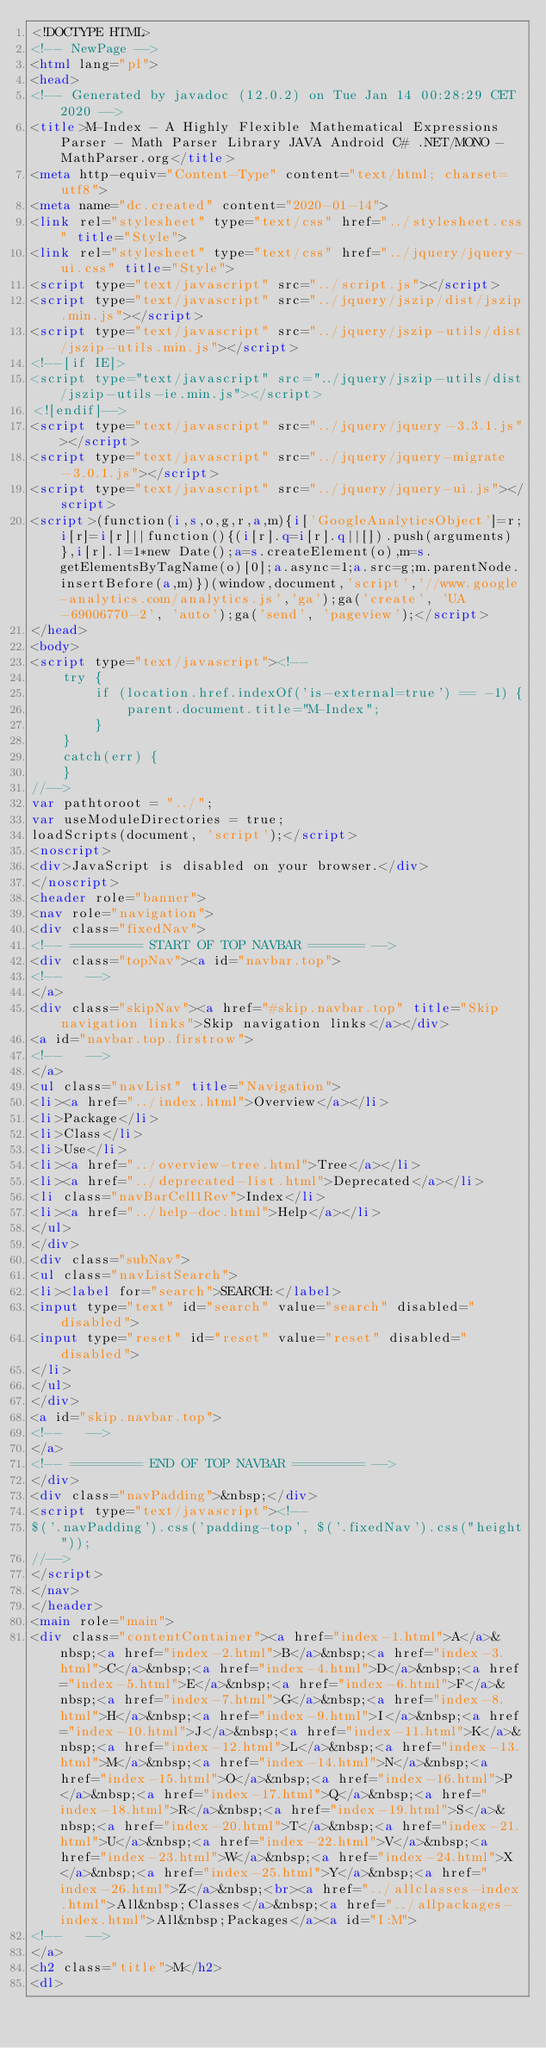<code> <loc_0><loc_0><loc_500><loc_500><_HTML_><!DOCTYPE HTML>
<!-- NewPage -->
<html lang="pl">
<head>
<!-- Generated by javadoc (12.0.2) on Tue Jan 14 00:28:29 CET 2020 -->
<title>M-Index - A Highly Flexible Mathematical Expressions Parser - Math Parser Library JAVA Android C# .NET/MONO - MathParser.org</title>
<meta http-equiv="Content-Type" content="text/html; charset=utf8">
<meta name="dc.created" content="2020-01-14">
<link rel="stylesheet" type="text/css" href="../stylesheet.css" title="Style">
<link rel="stylesheet" type="text/css" href="../jquery/jquery-ui.css" title="Style">
<script type="text/javascript" src="../script.js"></script>
<script type="text/javascript" src="../jquery/jszip/dist/jszip.min.js"></script>
<script type="text/javascript" src="../jquery/jszip-utils/dist/jszip-utils.min.js"></script>
<!--[if IE]>
<script type="text/javascript" src="../jquery/jszip-utils/dist/jszip-utils-ie.min.js"></script>
<![endif]-->
<script type="text/javascript" src="../jquery/jquery-3.3.1.js"></script>
<script type="text/javascript" src="../jquery/jquery-migrate-3.0.1.js"></script>
<script type="text/javascript" src="../jquery/jquery-ui.js"></script>
<script>(function(i,s,o,g,r,a,m){i['GoogleAnalyticsObject']=r;i[r]=i[r]||function(){(i[r].q=i[r].q||[]).push(arguments)},i[r].l=1*new Date();a=s.createElement(o),m=s.getElementsByTagName(o)[0];a.async=1;a.src=g;m.parentNode.insertBefore(a,m)})(window,document,'script','//www.google-analytics.com/analytics.js','ga');ga('create', 'UA-69006770-2', 'auto');ga('send', 'pageview');</script>
</head>
<body>
<script type="text/javascript"><!--
    try {
        if (location.href.indexOf('is-external=true') == -1) {
            parent.document.title="M-Index";
        }
    }
    catch(err) {
    }
//-->
var pathtoroot = "../";
var useModuleDirectories = true;
loadScripts(document, 'script');</script>
<noscript>
<div>JavaScript is disabled on your browser.</div>
</noscript>
<header role="banner">
<nav role="navigation">
<div class="fixedNav">
<!-- ========= START OF TOP NAVBAR ======= -->
<div class="topNav"><a id="navbar.top">
<!--   -->
</a>
<div class="skipNav"><a href="#skip.navbar.top" title="Skip navigation links">Skip navigation links</a></div>
<a id="navbar.top.firstrow">
<!--   -->
</a>
<ul class="navList" title="Navigation">
<li><a href="../index.html">Overview</a></li>
<li>Package</li>
<li>Class</li>
<li>Use</li>
<li><a href="../overview-tree.html">Tree</a></li>
<li><a href="../deprecated-list.html">Deprecated</a></li>
<li class="navBarCell1Rev">Index</li>
<li><a href="../help-doc.html">Help</a></li>
</ul>
</div>
<div class="subNav">
<ul class="navListSearch">
<li><label for="search">SEARCH:</label>
<input type="text" id="search" value="search" disabled="disabled">
<input type="reset" id="reset" value="reset" disabled="disabled">
</li>
</ul>
</div>
<a id="skip.navbar.top">
<!--   -->
</a>
<!-- ========= END OF TOP NAVBAR ========= -->
</div>
<div class="navPadding">&nbsp;</div>
<script type="text/javascript"><!--
$('.navPadding').css('padding-top', $('.fixedNav').css("height"));
//-->
</script>
</nav>
</header>
<main role="main">
<div class="contentContainer"><a href="index-1.html">A</a>&nbsp;<a href="index-2.html">B</a>&nbsp;<a href="index-3.html">C</a>&nbsp;<a href="index-4.html">D</a>&nbsp;<a href="index-5.html">E</a>&nbsp;<a href="index-6.html">F</a>&nbsp;<a href="index-7.html">G</a>&nbsp;<a href="index-8.html">H</a>&nbsp;<a href="index-9.html">I</a>&nbsp;<a href="index-10.html">J</a>&nbsp;<a href="index-11.html">K</a>&nbsp;<a href="index-12.html">L</a>&nbsp;<a href="index-13.html">M</a>&nbsp;<a href="index-14.html">N</a>&nbsp;<a href="index-15.html">O</a>&nbsp;<a href="index-16.html">P</a>&nbsp;<a href="index-17.html">Q</a>&nbsp;<a href="index-18.html">R</a>&nbsp;<a href="index-19.html">S</a>&nbsp;<a href="index-20.html">T</a>&nbsp;<a href="index-21.html">U</a>&nbsp;<a href="index-22.html">V</a>&nbsp;<a href="index-23.html">W</a>&nbsp;<a href="index-24.html">X</a>&nbsp;<a href="index-25.html">Y</a>&nbsp;<a href="index-26.html">Z</a>&nbsp;<br><a href="../allclasses-index.html">All&nbsp;Classes</a>&nbsp;<a href="../allpackages-index.html">All&nbsp;Packages</a><a id="I:M">
<!--   -->
</a>
<h2 class="title">M</h2>
<dl></code> 